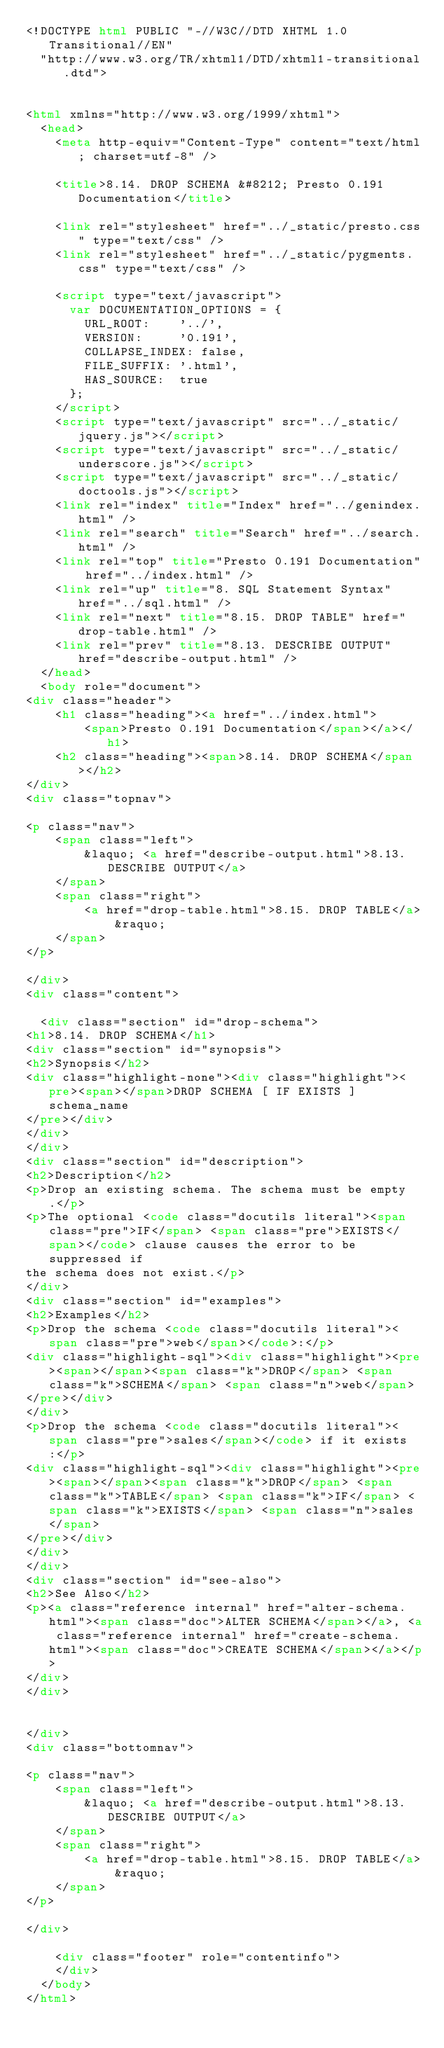Convert code to text. <code><loc_0><loc_0><loc_500><loc_500><_HTML_><!DOCTYPE html PUBLIC "-//W3C//DTD XHTML 1.0 Transitional//EN"
  "http://www.w3.org/TR/xhtml1/DTD/xhtml1-transitional.dtd">


<html xmlns="http://www.w3.org/1999/xhtml">
  <head>
    <meta http-equiv="Content-Type" content="text/html; charset=utf-8" />
    
    <title>8.14. DROP SCHEMA &#8212; Presto 0.191 Documentation</title>
    
    <link rel="stylesheet" href="../_static/presto.css" type="text/css" />
    <link rel="stylesheet" href="../_static/pygments.css" type="text/css" />
    
    <script type="text/javascript">
      var DOCUMENTATION_OPTIONS = {
        URL_ROOT:    '../',
        VERSION:     '0.191',
        COLLAPSE_INDEX: false,
        FILE_SUFFIX: '.html',
        HAS_SOURCE:  true
      };
    </script>
    <script type="text/javascript" src="../_static/jquery.js"></script>
    <script type="text/javascript" src="../_static/underscore.js"></script>
    <script type="text/javascript" src="../_static/doctools.js"></script>
    <link rel="index" title="Index" href="../genindex.html" />
    <link rel="search" title="Search" href="../search.html" />
    <link rel="top" title="Presto 0.191 Documentation" href="../index.html" />
    <link rel="up" title="8. SQL Statement Syntax" href="../sql.html" />
    <link rel="next" title="8.15. DROP TABLE" href="drop-table.html" />
    <link rel="prev" title="8.13. DESCRIBE OUTPUT" href="describe-output.html" /> 
  </head>
  <body role="document">
<div class="header">
    <h1 class="heading"><a href="../index.html">
        <span>Presto 0.191 Documentation</span></a></h1>
    <h2 class="heading"><span>8.14. DROP SCHEMA</span></h2>
</div>
<div class="topnav">
    
<p class="nav">
    <span class="left">
        &laquo; <a href="describe-output.html">8.13. DESCRIBE OUTPUT</a>
    </span>
    <span class="right">
        <a href="drop-table.html">8.15. DROP TABLE</a> &raquo;
    </span>
</p>

</div>
<div class="content">
    
  <div class="section" id="drop-schema">
<h1>8.14. DROP SCHEMA</h1>
<div class="section" id="synopsis">
<h2>Synopsis</h2>
<div class="highlight-none"><div class="highlight"><pre><span></span>DROP SCHEMA [ IF EXISTS ] schema_name
</pre></div>
</div>
</div>
<div class="section" id="description">
<h2>Description</h2>
<p>Drop an existing schema. The schema must be empty.</p>
<p>The optional <code class="docutils literal"><span class="pre">IF</span> <span class="pre">EXISTS</span></code> clause causes the error to be suppressed if
the schema does not exist.</p>
</div>
<div class="section" id="examples">
<h2>Examples</h2>
<p>Drop the schema <code class="docutils literal"><span class="pre">web</span></code>:</p>
<div class="highlight-sql"><div class="highlight"><pre><span></span><span class="k">DROP</span> <span class="k">SCHEMA</span> <span class="n">web</span>
</pre></div>
</div>
<p>Drop the schema <code class="docutils literal"><span class="pre">sales</span></code> if it exists:</p>
<div class="highlight-sql"><div class="highlight"><pre><span></span><span class="k">DROP</span> <span class="k">TABLE</span> <span class="k">IF</span> <span class="k">EXISTS</span> <span class="n">sales</span>
</pre></div>
</div>
</div>
<div class="section" id="see-also">
<h2>See Also</h2>
<p><a class="reference internal" href="alter-schema.html"><span class="doc">ALTER SCHEMA</span></a>, <a class="reference internal" href="create-schema.html"><span class="doc">CREATE SCHEMA</span></a></p>
</div>
</div>


</div>
<div class="bottomnav">
    
<p class="nav">
    <span class="left">
        &laquo; <a href="describe-output.html">8.13. DESCRIBE OUTPUT</a>
    </span>
    <span class="right">
        <a href="drop-table.html">8.15. DROP TABLE</a> &raquo;
    </span>
</p>

</div>

    <div class="footer" role="contentinfo">
    </div>
  </body>
</html></code> 